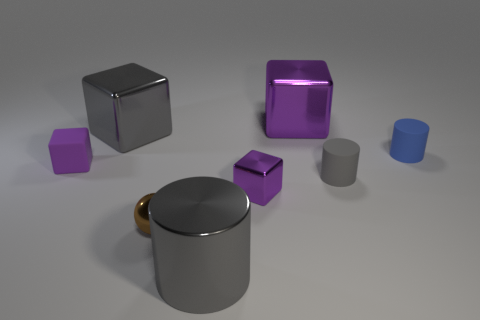There is a purple object that is to the left of the large gray shiny cylinder; is its size the same as the purple metallic block behind the big gray metallic cube?
Provide a succinct answer. No. What number of tiny purple things are there?
Your answer should be very brief. 2. There is a purple shiny block that is behind the gray shiny thing that is behind the blue matte cylinder that is behind the tiny brown shiny object; how big is it?
Your answer should be compact. Large. Does the metallic cylinder have the same color as the tiny ball?
Provide a succinct answer. No. Are there any other things that are the same size as the brown metal ball?
Your answer should be compact. Yes. What number of small objects are right of the tiny brown metallic object?
Provide a short and direct response. 3. Is the number of small purple cubes that are behind the gray rubber object the same as the number of rubber cubes?
Make the answer very short. Yes. What number of objects are purple objects or small blocks?
Your answer should be compact. 3. Is there any other thing that is the same shape as the small blue object?
Offer a very short reply. Yes. There is a gray thing that is to the right of the large cube that is behind the gray block; what shape is it?
Offer a terse response. Cylinder. 